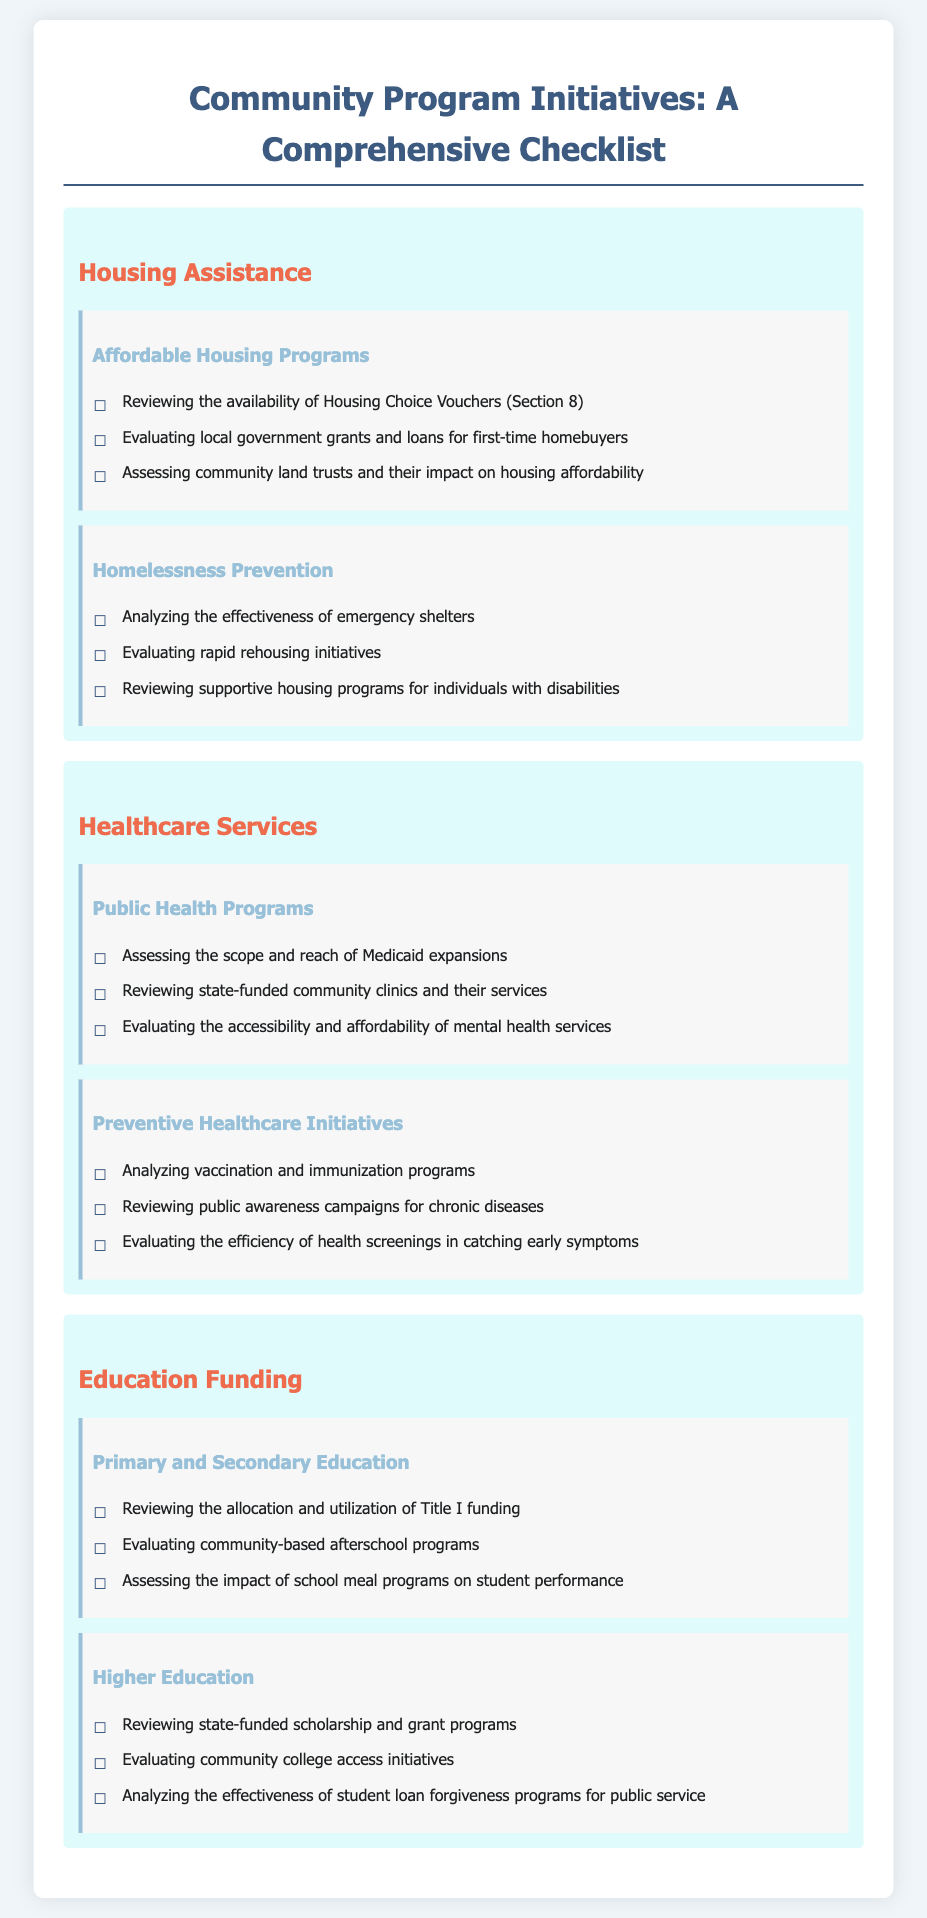what is the title of the document? The title is given at the top of the checklist, providing a clear focus on community program initiatives.
Answer: Community Program Initiatives: A Comprehensive Checklist how many sections are in the Housing Assistance category? The document lists two distinct subsections under Housing Assistance.
Answer: 2 what type of support does Medicaid expansions provide? Medicaid expansions are designed to enhance public health programs by increasing access to healthcare.
Answer: public health how many factors are listed under Healthcare Services? The document includes a total of six enumerated factors within the Healthcare Services section.
Answer: 6 which program assesses the impact on student performance? The document references school meal programs as a factor that assesses student performance impact in education.
Answer: school meal programs what is one initiative evaluated for homelessness prevention? The checklist mentions rapid rehousing initiatives as a key evaluation area in homelessness prevention.
Answer: rapid rehousing initiatives what funding is reviewed under Primary and Secondary Education? Title I funding is a significant area reviewed in the context of education funding.
Answer: Title I funding how many subsections are under Higher Education? The document categorizes Higher Education into three specific subsections.
Answer: 3 what does the document assess regarding community clinics? The assessment focuses on state-funded community clinics and the services they provide.
Answer: services 